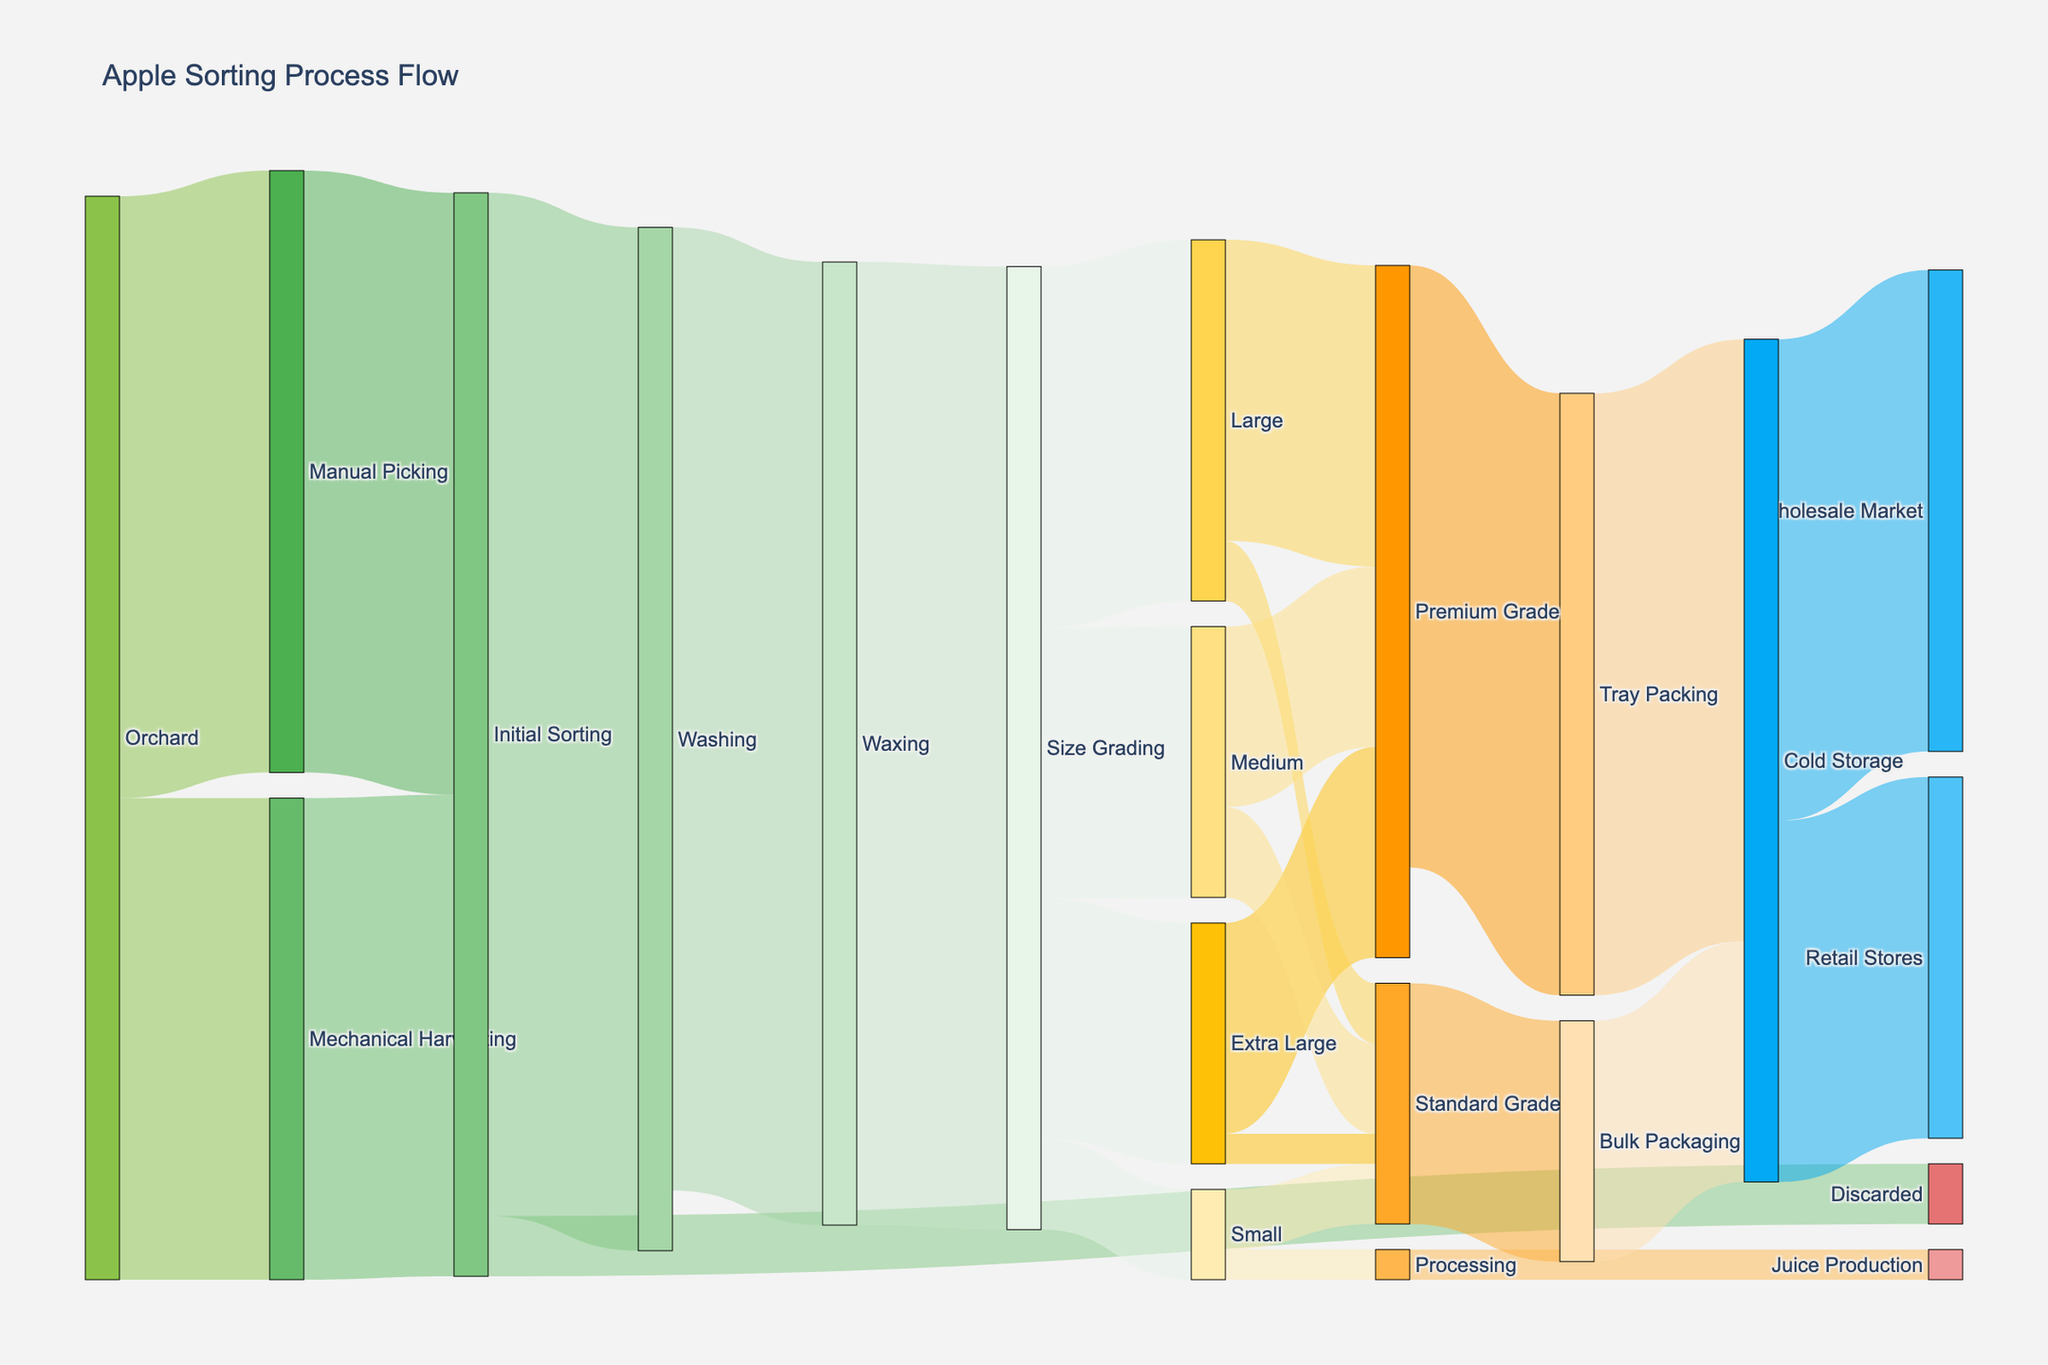What is the title of the Sankey diagram? The title of the Sankey diagram is usually displayed at the top of the figure. From the provided information, the title is "Apple Sorting Process Flow."
Answer: Apple Sorting Process Flow How many apples in the initial sorting stage are discarded? By following the flows in the diagram, we can see that 100 apples are discarded during the initial sorting stage.
Answer: 100 What is the total number of apples obtained from Manual Picking and Mechanical Harvesting combined? The total number of apples from both sources can be obtained by adding the values from Manual Picking (1000) and Mechanical Harvesting (800). 1000 + 800 = 1800
Answer: 1800 After the waxing stage, how many apples are sent to the size grading stage? According to the diagram, all 1600 apples from the waxing stage proceed to the size grading stage.
Answer: 1600 How many apples are categorized as Extra Large after size grading? The diagram shows that 400 apples are classified as Extra Large after the size grading stage.
Answer: 400 Which category contributes the most to the Premium Grade, and how many apples does it contribute? By comparing the contributions to Premium Grade from all sizes, we see that the Large category contributes the most, with 500 apples.
Answer: Large, 500 How many apples are finally sent to Retail Stores from Cold Storage? Following the Sankey flows, 600 apples are sent to Retail Stores from Cold Storage.
Answer: 600 What is the difference between the number of apples in the Premium Grade and the Standard Grade after size grading? The diagram shows there are 1150 apples in Premium Grade (350 Extra Large + 500 Large + 300 Medium) and 400 in Standard Grade (50 Extra Large + 100 Large + 150 Medium + 100 Small). The difference is 1150 - 400 = 750.
Answer: 750 What proportion of Medium apples in size grading go to the Standard Grade? From the size grading stage, 450 apples are Medium. 150 of these go to the Standard Grade. The proportion is 150/450 = 1/3.
Answer: 1/3 